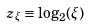Convert formula to latex. <formula><loc_0><loc_0><loc_500><loc_500>z _ { \xi } \equiv \log _ { 2 } ( \xi )</formula> 